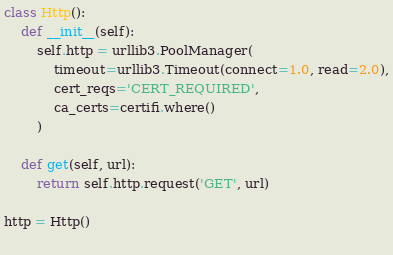Convert code to text. <code><loc_0><loc_0><loc_500><loc_500><_Python_>

class Http():
    def __init__(self):
        self.http = urllib3.PoolManager(
            timeout=urllib3.Timeout(connect=1.0, read=2.0),
            cert_reqs='CERT_REQUIRED',
            ca_certs=certifi.where()
        )

    def get(self, url):
        return self.http.request('GET', url)

http = Http()
        </code> 